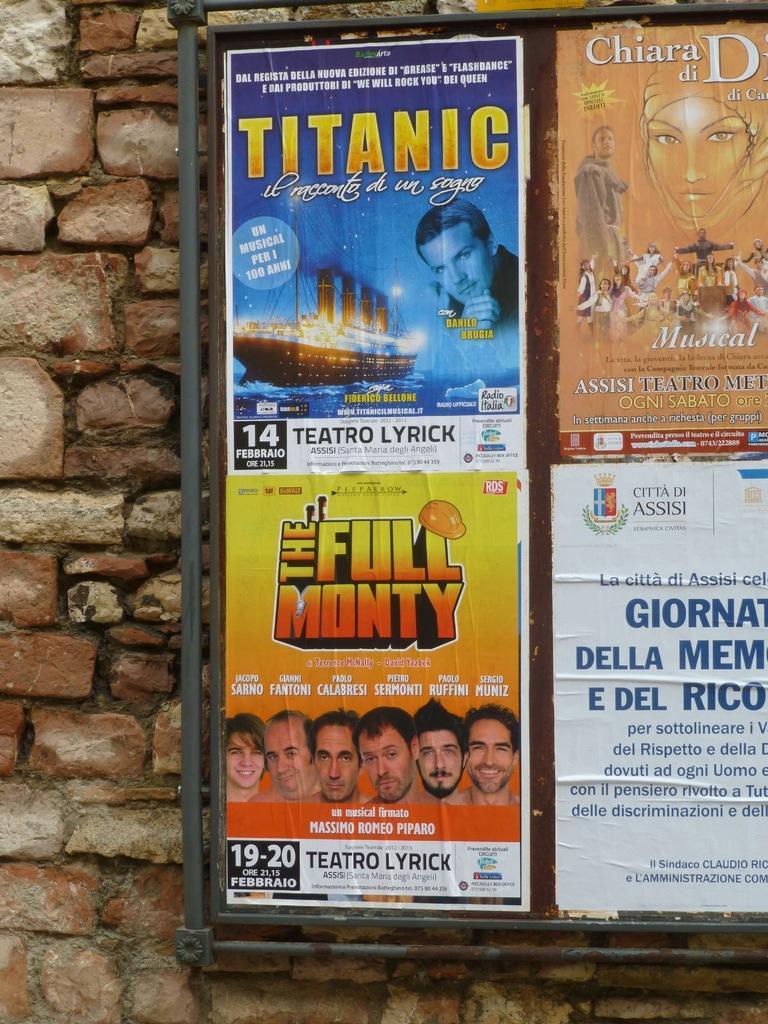Please provide a concise description of this image. In this image there are posters on the wall with some text and images on it. 